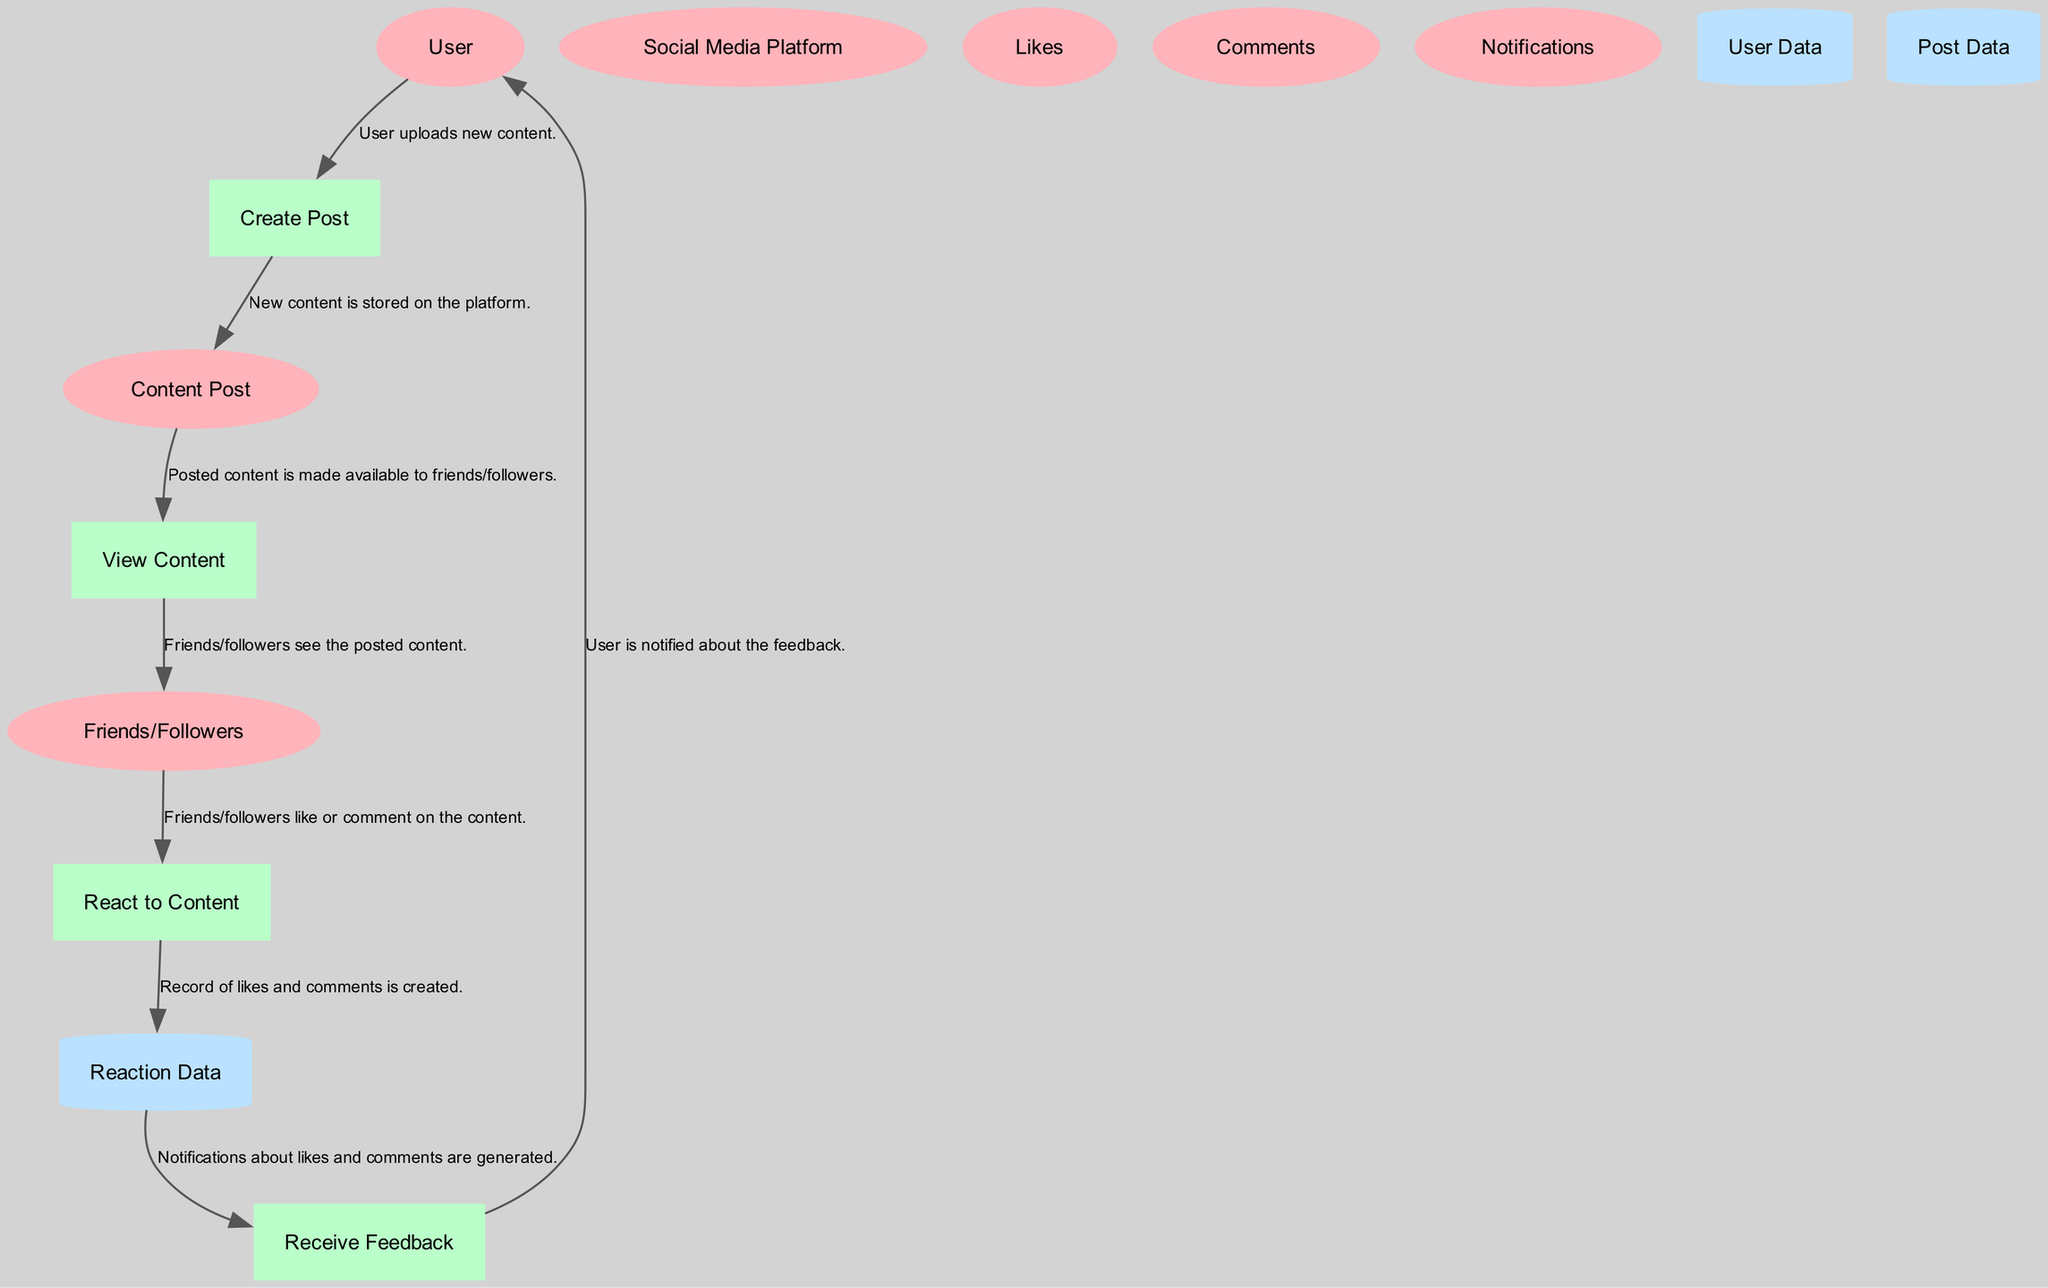What is the first process in the diagram? The first process in the diagram is "Create Post," which follows the "User" entity. This indicates that the process of creating a post is initiated by the user.
Answer: Create Post How many entities are present in the diagram? The diagram contains six entities including User, Social Media Platform, Content Post, Friends/Followers, Likes, and Comments. This is counted from the list of entities provided.
Answer: 6 What do friends/followers do with posted content? Friends/followers interact with the posted content by viewing it, liking it, or leaving comments as indicated by the "View Content" and "React to Content" processes.
Answer: View and react What type of data store is "Reaction Data"? "Reaction Data" is categorized as a data store in the diagram, and specifically, it is represented as a cylinder, which is a conventional symbol for data stores in data flow diagrams.
Answer: Cylinder Which entity receives notifications about likes and comments? The "User" entity receives notifications about the likes and comments on their content post, as indicated by the "Receive Feedback" process directing to the User.
Answer: User What action is taken after friends/followers react to content? After friends/followers react to the content, the data about these reactions is recorded in the "Reaction Data" store, which captures likes and comments as interactions.
Answer: Record reactions Which process generates notifications along with the likes and comments? The "Receive Feedback" process generates notifications regarding the likes and comments received on a user's content post. This process specifically handles feedback generation.
Answer: Receive Feedback What data flows from the "View Content" to "Friends/Followers"? The data flow from "View Content" to "Friends/Followers" represents the friends/followers viewing the posted content after it is made available on their feed.
Answer: Posted content 